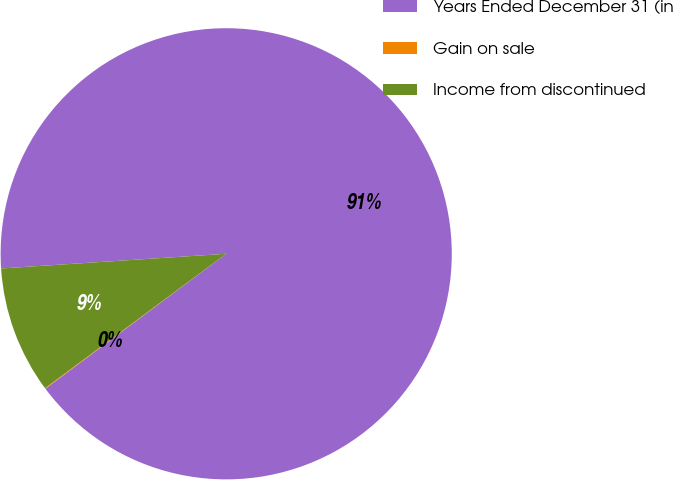<chart> <loc_0><loc_0><loc_500><loc_500><pie_chart><fcel>Years Ended December 31 (in<fcel>Gain on sale<fcel>Income from discontinued<nl><fcel>90.83%<fcel>0.05%<fcel>9.12%<nl></chart> 